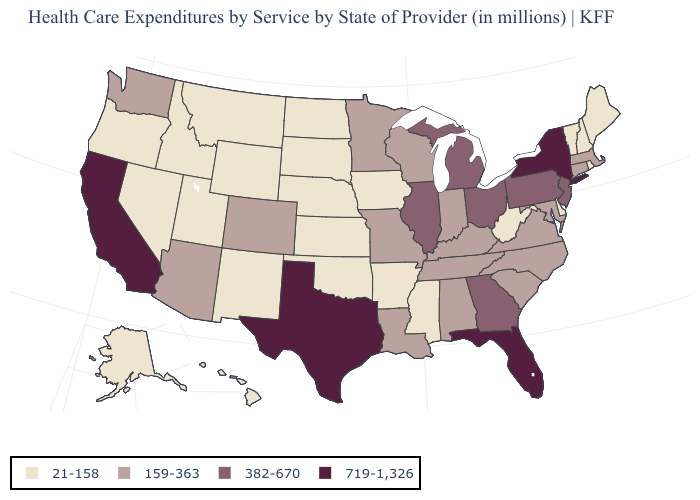What is the value of Alaska?
Answer briefly. 21-158. Which states have the highest value in the USA?
Quick response, please. California, Florida, New York, Texas. Name the states that have a value in the range 159-363?
Answer briefly. Alabama, Arizona, Colorado, Connecticut, Indiana, Kentucky, Louisiana, Maryland, Massachusetts, Minnesota, Missouri, North Carolina, South Carolina, Tennessee, Virginia, Washington, Wisconsin. What is the value of South Carolina?
Answer briefly. 159-363. What is the value of Louisiana?
Short answer required. 159-363. Which states have the lowest value in the USA?
Be succinct. Alaska, Arkansas, Delaware, Hawaii, Idaho, Iowa, Kansas, Maine, Mississippi, Montana, Nebraska, Nevada, New Hampshire, New Mexico, North Dakota, Oklahoma, Oregon, Rhode Island, South Dakota, Utah, Vermont, West Virginia, Wyoming. Does the map have missing data?
Concise answer only. No. What is the value of Rhode Island?
Keep it brief. 21-158. What is the value of Kansas?
Short answer required. 21-158. Among the states that border West Virginia , does Pennsylvania have the lowest value?
Quick response, please. No. Among the states that border Texas , does New Mexico have the highest value?
Answer briefly. No. Does Indiana have a higher value than Connecticut?
Answer briefly. No. What is the highest value in the USA?
Answer briefly. 719-1,326. What is the lowest value in the MidWest?
Keep it brief. 21-158. What is the value of California?
Write a very short answer. 719-1,326. 